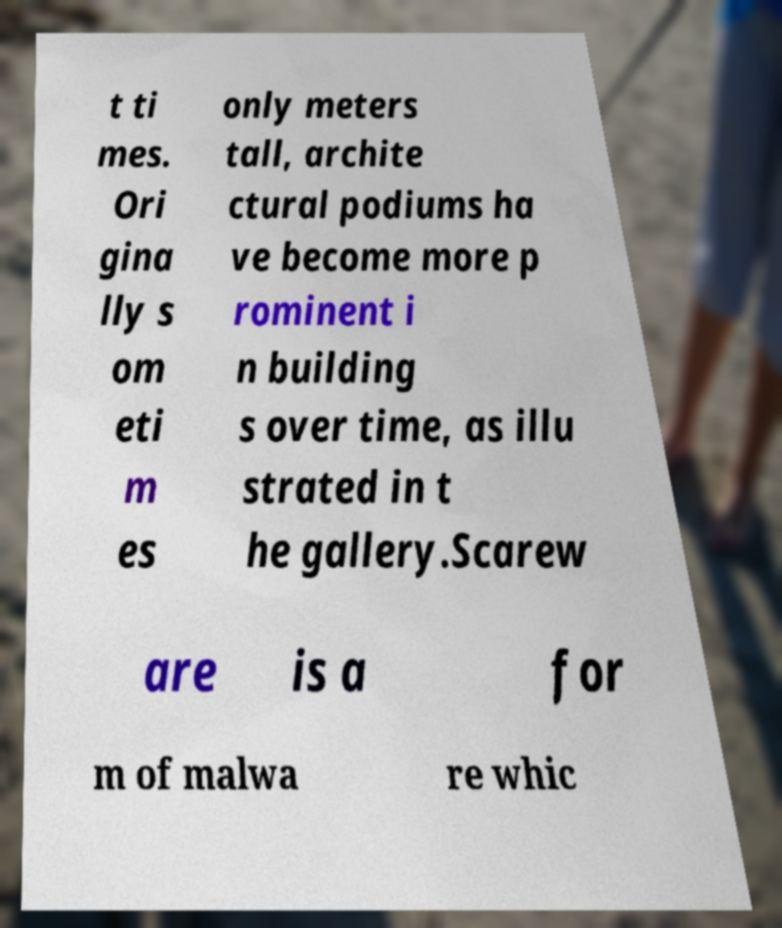Can you accurately transcribe the text from the provided image for me? t ti mes. Ori gina lly s om eti m es only meters tall, archite ctural podiums ha ve become more p rominent i n building s over time, as illu strated in t he gallery.Scarew are is a for m of malwa re whic 